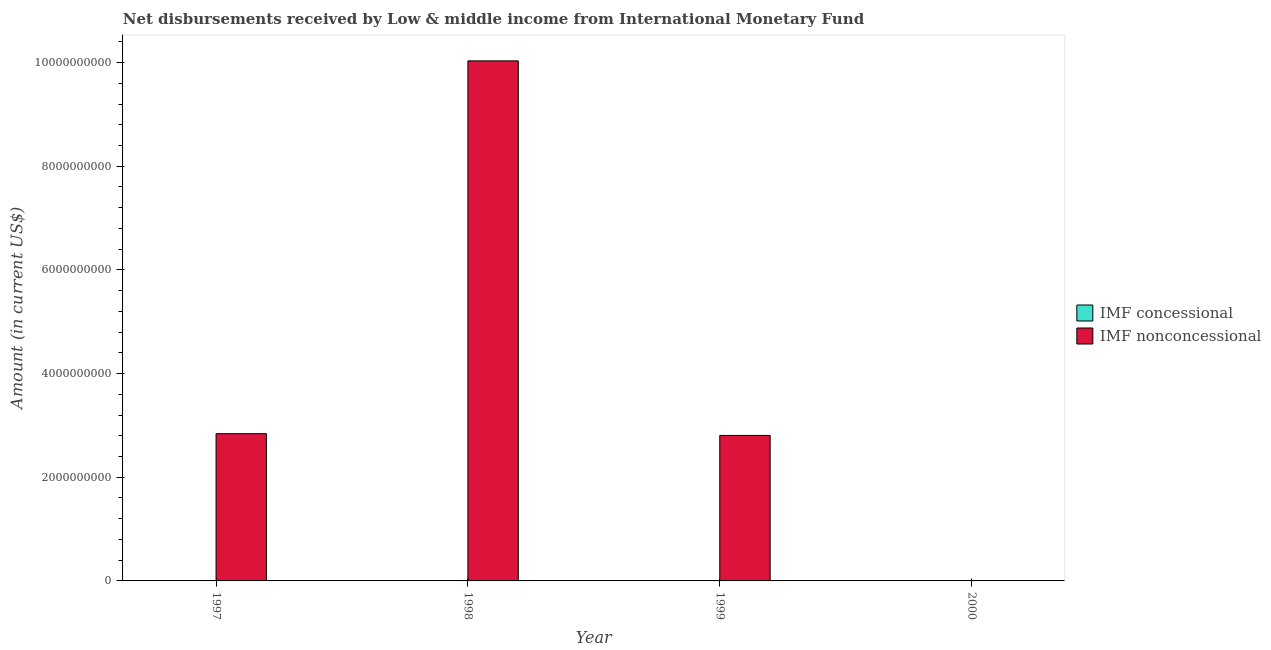How many different coloured bars are there?
Your answer should be very brief. 2. Are the number of bars on each tick of the X-axis equal?
Your response must be concise. No. What is the label of the 3rd group of bars from the left?
Your answer should be very brief. 1999. In how many cases, is the number of bars for a given year not equal to the number of legend labels?
Ensure brevity in your answer.  3. Across all years, what is the maximum net non concessional disbursements from imf?
Provide a short and direct response. 1.00e+1. What is the total net concessional disbursements from imf in the graph?
Provide a short and direct response. 2.32e+06. What is the difference between the net non concessional disbursements from imf in 1997 and that in 1999?
Provide a short and direct response. 3.42e+07. What is the difference between the net non concessional disbursements from imf in 2000 and the net concessional disbursements from imf in 1999?
Your answer should be compact. -2.81e+09. What is the average net non concessional disbursements from imf per year?
Provide a succinct answer. 3.92e+09. What is the ratio of the net non concessional disbursements from imf in 1998 to that in 1999?
Offer a terse response. 3.57. Is the difference between the net non concessional disbursements from imf in 1998 and 1999 greater than the difference between the net concessional disbursements from imf in 1998 and 1999?
Make the answer very short. No. What is the difference between the highest and the second highest net non concessional disbursements from imf?
Your answer should be compact. 7.19e+09. What is the difference between the highest and the lowest net concessional disbursements from imf?
Provide a succinct answer. 2.32e+06. In how many years, is the net non concessional disbursements from imf greater than the average net non concessional disbursements from imf taken over all years?
Your response must be concise. 1. Is the sum of the net non concessional disbursements from imf in 1997 and 1999 greater than the maximum net concessional disbursements from imf across all years?
Ensure brevity in your answer.  No. How many bars are there?
Your answer should be very brief. 4. How many years are there in the graph?
Your answer should be compact. 4. What is the difference between two consecutive major ticks on the Y-axis?
Give a very brief answer. 2.00e+09. Are the values on the major ticks of Y-axis written in scientific E-notation?
Your answer should be very brief. No. Does the graph contain any zero values?
Ensure brevity in your answer.  Yes. Where does the legend appear in the graph?
Give a very brief answer. Center right. What is the title of the graph?
Your answer should be compact. Net disbursements received by Low & middle income from International Monetary Fund. Does "Subsidies" appear as one of the legend labels in the graph?
Offer a very short reply. No. What is the Amount (in current US$) of IMF nonconcessional in 1997?
Your answer should be very brief. 2.84e+09. What is the Amount (in current US$) in IMF concessional in 1998?
Keep it short and to the point. 2.32e+06. What is the Amount (in current US$) of IMF nonconcessional in 1998?
Provide a short and direct response. 1.00e+1. What is the Amount (in current US$) in IMF concessional in 1999?
Give a very brief answer. 0. What is the Amount (in current US$) of IMF nonconcessional in 1999?
Provide a short and direct response. 2.81e+09. What is the Amount (in current US$) in IMF nonconcessional in 2000?
Your response must be concise. 0. Across all years, what is the maximum Amount (in current US$) of IMF concessional?
Give a very brief answer. 2.32e+06. Across all years, what is the maximum Amount (in current US$) in IMF nonconcessional?
Make the answer very short. 1.00e+1. What is the total Amount (in current US$) of IMF concessional in the graph?
Provide a short and direct response. 2.32e+06. What is the total Amount (in current US$) of IMF nonconcessional in the graph?
Your answer should be compact. 1.57e+1. What is the difference between the Amount (in current US$) of IMF nonconcessional in 1997 and that in 1998?
Your answer should be compact. -7.19e+09. What is the difference between the Amount (in current US$) in IMF nonconcessional in 1997 and that in 1999?
Your answer should be very brief. 3.42e+07. What is the difference between the Amount (in current US$) in IMF nonconcessional in 1998 and that in 1999?
Your answer should be compact. 7.23e+09. What is the difference between the Amount (in current US$) in IMF concessional in 1998 and the Amount (in current US$) in IMF nonconcessional in 1999?
Ensure brevity in your answer.  -2.80e+09. What is the average Amount (in current US$) in IMF concessional per year?
Give a very brief answer. 5.81e+05. What is the average Amount (in current US$) of IMF nonconcessional per year?
Your answer should be compact. 3.92e+09. In the year 1998, what is the difference between the Amount (in current US$) in IMF concessional and Amount (in current US$) in IMF nonconcessional?
Provide a short and direct response. -1.00e+1. What is the ratio of the Amount (in current US$) of IMF nonconcessional in 1997 to that in 1998?
Provide a succinct answer. 0.28. What is the ratio of the Amount (in current US$) in IMF nonconcessional in 1997 to that in 1999?
Give a very brief answer. 1.01. What is the ratio of the Amount (in current US$) of IMF nonconcessional in 1998 to that in 1999?
Ensure brevity in your answer.  3.57. What is the difference between the highest and the second highest Amount (in current US$) of IMF nonconcessional?
Ensure brevity in your answer.  7.19e+09. What is the difference between the highest and the lowest Amount (in current US$) of IMF concessional?
Provide a short and direct response. 2.32e+06. What is the difference between the highest and the lowest Amount (in current US$) of IMF nonconcessional?
Ensure brevity in your answer.  1.00e+1. 